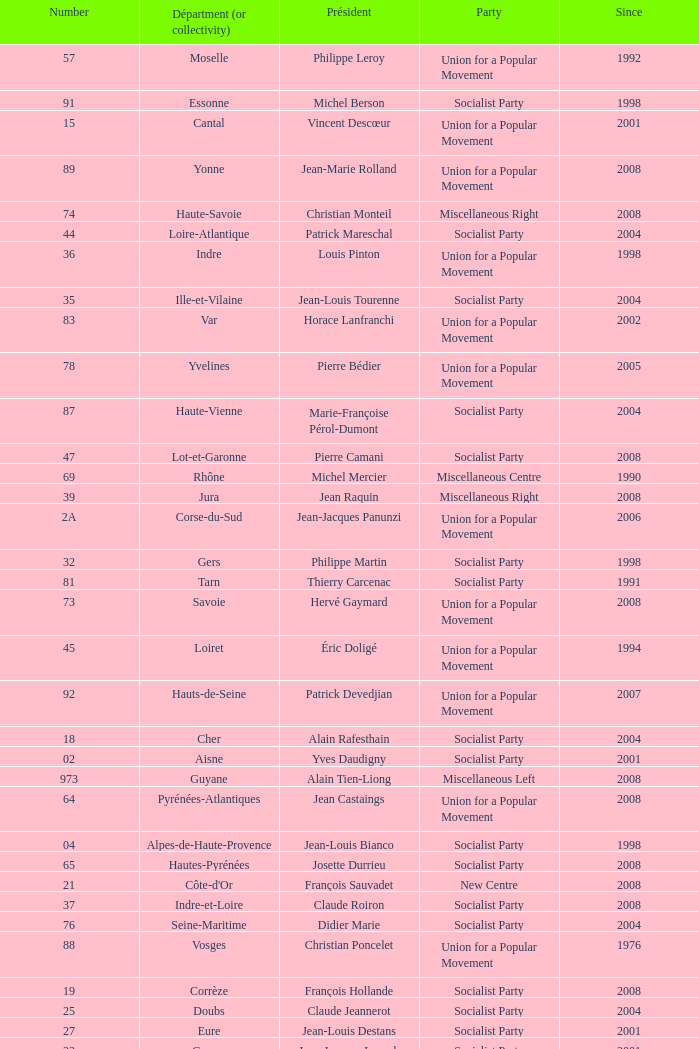Who is the president representing the Creuse department? Jean-Jacques Lozach. 